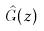Convert formula to latex. <formula><loc_0><loc_0><loc_500><loc_500>\hat { G } ( z )</formula> 